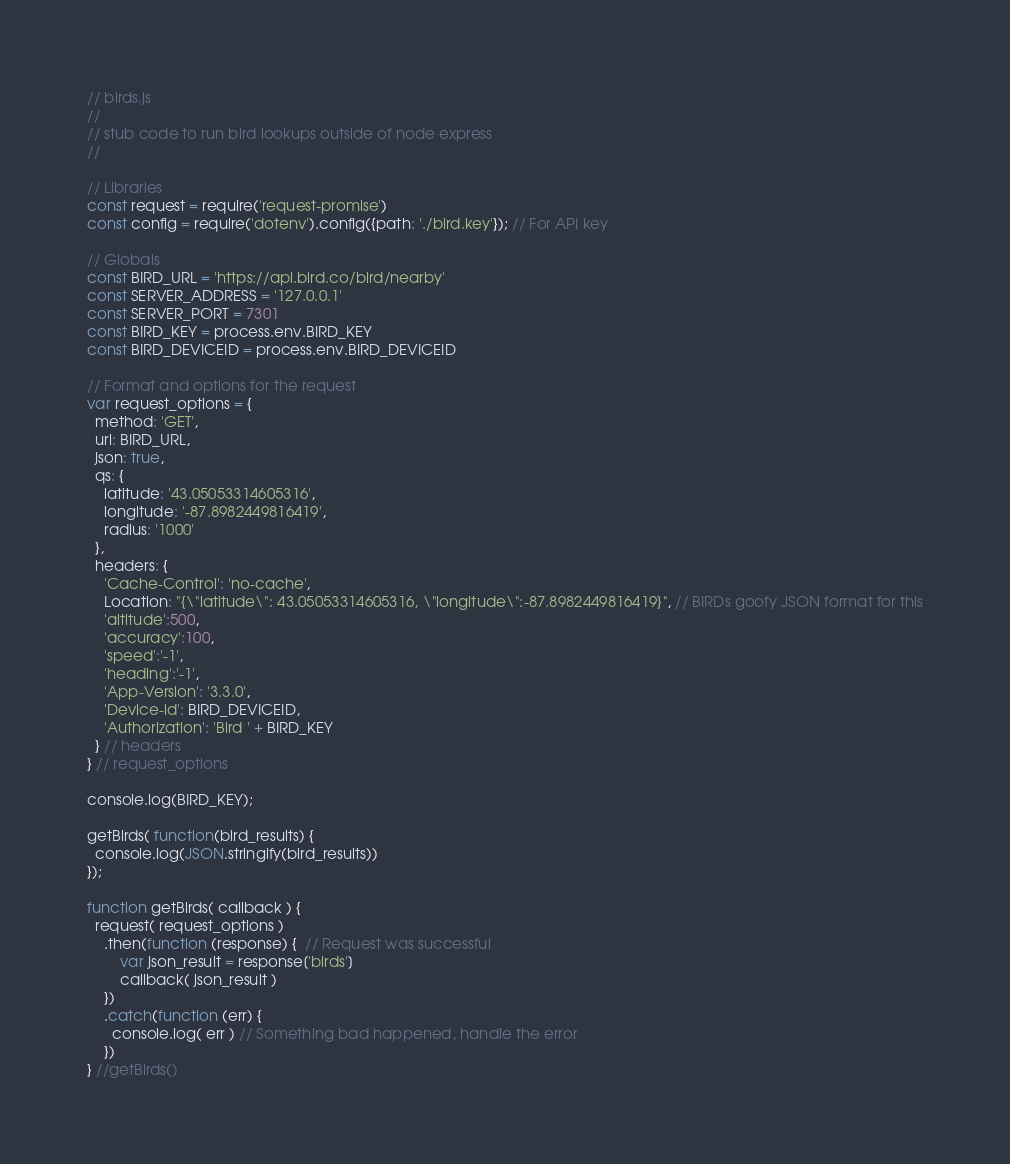<code> <loc_0><loc_0><loc_500><loc_500><_JavaScript_>// birds.js
//
// stub code to run bird lookups outside of node express
//

// Libraries
const request = require('request-promise')
const config = require('dotenv').config({path: './bird.key'}); // For API key

// Globals
const BIRD_URL = 'https://api.bird.co/bird/nearby'
const SERVER_ADDRESS = '127.0.0.1'
const SERVER_PORT = 7301
const BIRD_KEY = process.env.BIRD_KEY
const BIRD_DEVICEID = process.env.BIRD_DEVICEID

// Format and options for the request
var request_options = {
  method: 'GET',
  uri: BIRD_URL,
  json: true,
  qs: {
    latitude: '43.05053314605316',
    longitude: '-87.8982449816419',
    radius: '1000'
  },
  headers: {
    'Cache-Control': 'no-cache',
    Location: "{\"latitude\": 43.05053314605316, \"longitude\":-87.8982449816419}", // BIRDs goofy JSON format for this
    'altitude':500,
    'accuracy':100,
    'speed':'-1',
    'heading':'-1',
    'App-Version': '3.3.0',
    'Device-id': BIRD_DEVICEID,
    'Authorization': 'Bird ' + BIRD_KEY
  } // headers
} // request_options

console.log(BIRD_KEY);

getBirds( function(bird_results) {
  console.log(JSON.stringify(bird_results))
});

function getBirds( callback ) {
  request( request_options )
    .then(function (response) {  // Request was successful
        var json_result = response['birds']
        callback( json_result )
    })
    .catch(function (err) {
      console.log( err ) // Something bad happened, handle the error
    })
} //getBirds()
</code> 